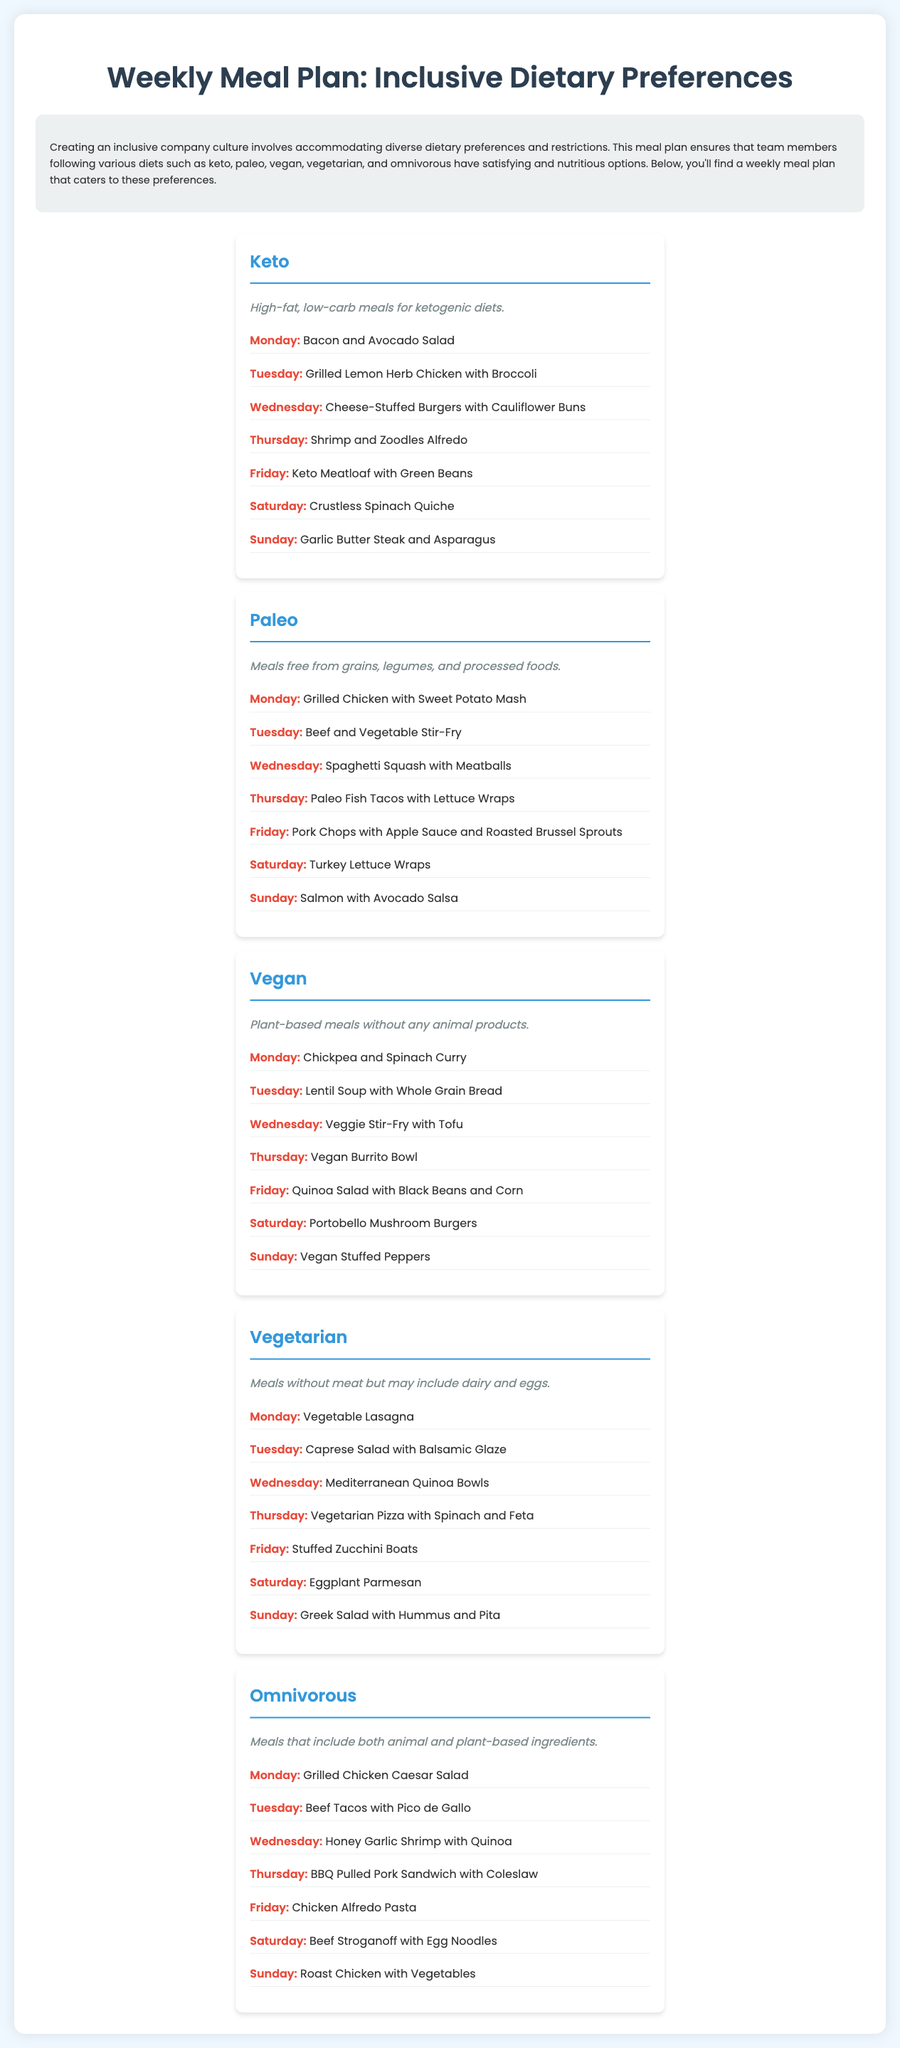What is the title of the document? The title is stated at the top of the document under the heading.
Answer: Weekly Meal Plan: Inclusive Dietary Preferences What meal is served on Wednesday for the Keto diet? This information is retrieved from the list of meals for the Keto diet.
Answer: Cheese-Stuffed Burgers with Cauliflower Buns Which day features Salmon with Avocado Salsa in the Paleo meal plan? This requires finding the specific day assigned to this meal in the Paleo section.
Answer: Sunday How many meals are listed for the Vegan diet? This is determined by counting the listed meals in the Vegan section.
Answer: 7 What is a key characteristic of the Vegetarian meals? This is identified from the description provided in the Vegetarian section of the document.
Answer: Meals without meat Which dietary preference includes BBQ Pulled Pork Sandwiches? This can be found by looking at the meals listed under the relevant dietary category.
Answer: Omnivorous What type of meal plan is this document classified as? This can be identified by looking at the purpose stated in the introduction of the document.
Answer: Inclusive Meal Plan What is the main dietary focus of the meals listed as Keto? This can be found in the Keto section description.
Answer: High-fat, low-carb meals 